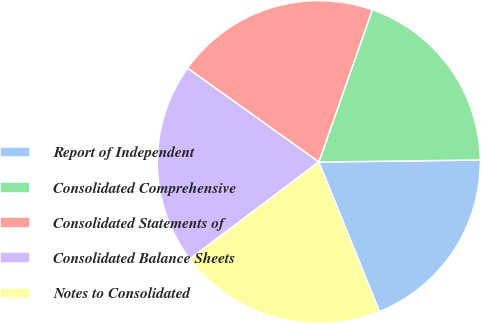Convert chart. <chart><loc_0><loc_0><loc_500><loc_500><pie_chart><fcel>Report of Independent<fcel>Consolidated Comprehensive<fcel>Consolidated Statements of<fcel>Consolidated Balance Sheets<fcel>Notes to Consolidated<nl><fcel>19.06%<fcel>19.42%<fcel>20.5%<fcel>20.14%<fcel>20.86%<nl></chart> 